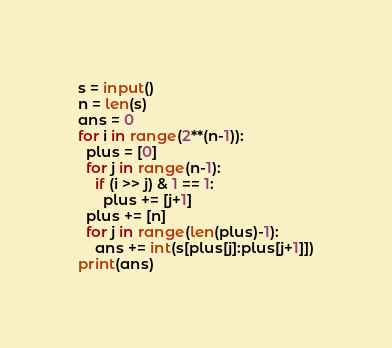Convert code to text. <code><loc_0><loc_0><loc_500><loc_500><_Python_>s = input()
n = len(s)
ans = 0
for i in range(2**(n-1)):
  plus = [0]
  for j in range(n-1):
    if (i >> j) & 1 == 1:
      plus += [j+1]
  plus += [n]
  for j in range(len(plus)-1):
    ans += int(s[plus[j]:plus[j+1]])
print(ans)    </code> 